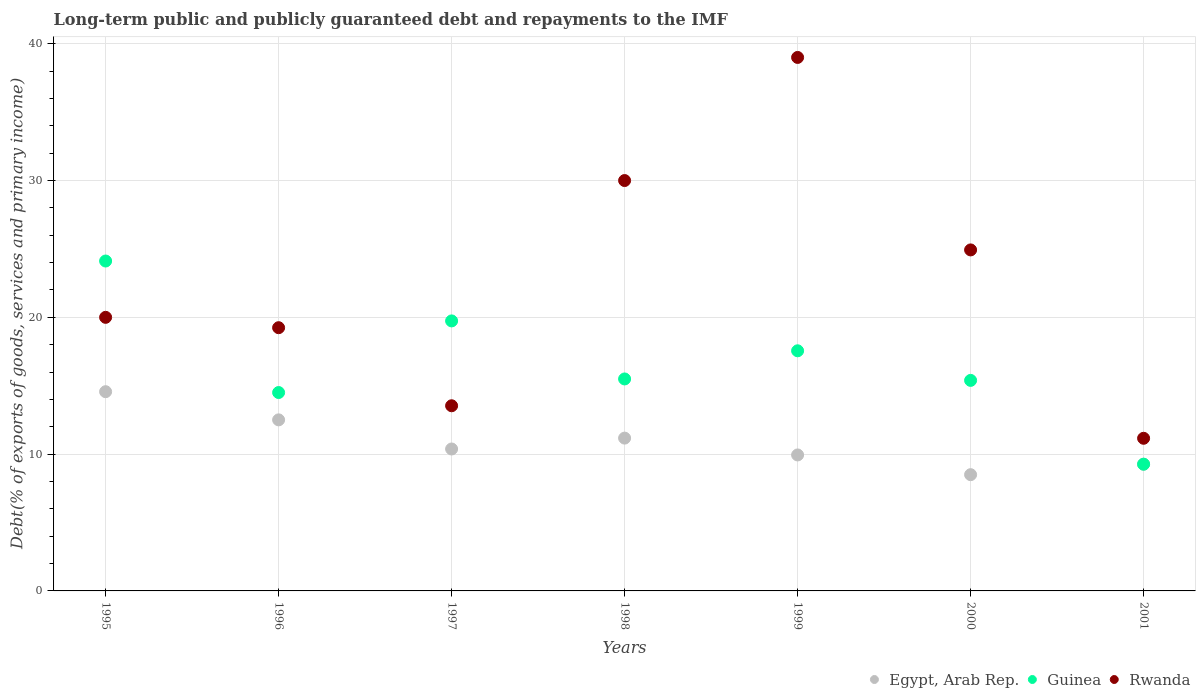How many different coloured dotlines are there?
Your answer should be compact. 3. Is the number of dotlines equal to the number of legend labels?
Offer a very short reply. Yes. What is the debt and repayments in Guinea in 1995?
Your answer should be compact. 24.12. Across all years, what is the maximum debt and repayments in Rwanda?
Offer a terse response. 39. Across all years, what is the minimum debt and repayments in Rwanda?
Make the answer very short. 11.16. What is the total debt and repayments in Guinea in the graph?
Keep it short and to the point. 116.06. What is the difference between the debt and repayments in Guinea in 1995 and that in 1997?
Your answer should be very brief. 4.38. What is the difference between the debt and repayments in Guinea in 1997 and the debt and repayments in Rwanda in 2001?
Make the answer very short. 8.58. What is the average debt and repayments in Guinea per year?
Your answer should be very brief. 16.58. In the year 2001, what is the difference between the debt and repayments in Egypt, Arab Rep. and debt and repayments in Guinea?
Provide a short and direct response. -0. What is the ratio of the debt and repayments in Rwanda in 1999 to that in 2001?
Give a very brief answer. 3.5. Is the debt and repayments in Guinea in 1995 less than that in 1997?
Your response must be concise. No. Is the difference between the debt and repayments in Egypt, Arab Rep. in 1996 and 1997 greater than the difference between the debt and repayments in Guinea in 1996 and 1997?
Ensure brevity in your answer.  Yes. What is the difference between the highest and the second highest debt and repayments in Rwanda?
Offer a very short reply. 9. What is the difference between the highest and the lowest debt and repayments in Egypt, Arab Rep.?
Offer a very short reply. 6.07. In how many years, is the debt and repayments in Rwanda greater than the average debt and repayments in Rwanda taken over all years?
Make the answer very short. 3. Is it the case that in every year, the sum of the debt and repayments in Guinea and debt and repayments in Egypt, Arab Rep.  is greater than the debt and repayments in Rwanda?
Offer a terse response. No. Does the debt and repayments in Rwanda monotonically increase over the years?
Your response must be concise. No. Is the debt and repayments in Guinea strictly less than the debt and repayments in Rwanda over the years?
Offer a very short reply. No. How many dotlines are there?
Keep it short and to the point. 3. What is the difference between two consecutive major ticks on the Y-axis?
Provide a succinct answer. 10. Does the graph contain grids?
Provide a succinct answer. Yes. Where does the legend appear in the graph?
Keep it short and to the point. Bottom right. How many legend labels are there?
Provide a short and direct response. 3. How are the legend labels stacked?
Your answer should be compact. Horizontal. What is the title of the graph?
Offer a terse response. Long-term public and publicly guaranteed debt and repayments to the IMF. Does "Gabon" appear as one of the legend labels in the graph?
Your response must be concise. No. What is the label or title of the X-axis?
Your answer should be compact. Years. What is the label or title of the Y-axis?
Your answer should be very brief. Debt(% of exports of goods, services and primary income). What is the Debt(% of exports of goods, services and primary income) of Egypt, Arab Rep. in 1995?
Make the answer very short. 14.56. What is the Debt(% of exports of goods, services and primary income) of Guinea in 1995?
Your response must be concise. 24.12. What is the Debt(% of exports of goods, services and primary income) of Rwanda in 1995?
Provide a succinct answer. 20. What is the Debt(% of exports of goods, services and primary income) of Egypt, Arab Rep. in 1996?
Offer a very short reply. 12.51. What is the Debt(% of exports of goods, services and primary income) in Guinea in 1996?
Give a very brief answer. 14.5. What is the Debt(% of exports of goods, services and primary income) of Rwanda in 1996?
Your answer should be very brief. 19.24. What is the Debt(% of exports of goods, services and primary income) of Egypt, Arab Rep. in 1997?
Keep it short and to the point. 10.38. What is the Debt(% of exports of goods, services and primary income) in Guinea in 1997?
Provide a short and direct response. 19.74. What is the Debt(% of exports of goods, services and primary income) in Rwanda in 1997?
Offer a terse response. 13.54. What is the Debt(% of exports of goods, services and primary income) of Egypt, Arab Rep. in 1998?
Ensure brevity in your answer.  11.17. What is the Debt(% of exports of goods, services and primary income) of Guinea in 1998?
Ensure brevity in your answer.  15.5. What is the Debt(% of exports of goods, services and primary income) in Rwanda in 1998?
Your answer should be very brief. 30. What is the Debt(% of exports of goods, services and primary income) of Egypt, Arab Rep. in 1999?
Your answer should be compact. 9.94. What is the Debt(% of exports of goods, services and primary income) of Guinea in 1999?
Provide a succinct answer. 17.55. What is the Debt(% of exports of goods, services and primary income) of Rwanda in 1999?
Give a very brief answer. 39. What is the Debt(% of exports of goods, services and primary income) in Egypt, Arab Rep. in 2000?
Keep it short and to the point. 8.5. What is the Debt(% of exports of goods, services and primary income) of Guinea in 2000?
Offer a terse response. 15.39. What is the Debt(% of exports of goods, services and primary income) in Rwanda in 2000?
Offer a very short reply. 24.93. What is the Debt(% of exports of goods, services and primary income) in Egypt, Arab Rep. in 2001?
Provide a succinct answer. 9.26. What is the Debt(% of exports of goods, services and primary income) of Guinea in 2001?
Make the answer very short. 9.26. What is the Debt(% of exports of goods, services and primary income) in Rwanda in 2001?
Keep it short and to the point. 11.16. Across all years, what is the maximum Debt(% of exports of goods, services and primary income) in Egypt, Arab Rep.?
Give a very brief answer. 14.56. Across all years, what is the maximum Debt(% of exports of goods, services and primary income) of Guinea?
Ensure brevity in your answer.  24.12. Across all years, what is the minimum Debt(% of exports of goods, services and primary income) of Egypt, Arab Rep.?
Provide a succinct answer. 8.5. Across all years, what is the minimum Debt(% of exports of goods, services and primary income) of Guinea?
Your response must be concise. 9.26. Across all years, what is the minimum Debt(% of exports of goods, services and primary income) of Rwanda?
Provide a succinct answer. 11.16. What is the total Debt(% of exports of goods, services and primary income) of Egypt, Arab Rep. in the graph?
Your answer should be compact. 76.32. What is the total Debt(% of exports of goods, services and primary income) in Guinea in the graph?
Keep it short and to the point. 116.06. What is the total Debt(% of exports of goods, services and primary income) of Rwanda in the graph?
Your response must be concise. 157.87. What is the difference between the Debt(% of exports of goods, services and primary income) of Egypt, Arab Rep. in 1995 and that in 1996?
Provide a short and direct response. 2.06. What is the difference between the Debt(% of exports of goods, services and primary income) in Guinea in 1995 and that in 1996?
Ensure brevity in your answer.  9.61. What is the difference between the Debt(% of exports of goods, services and primary income) of Rwanda in 1995 and that in 1996?
Your response must be concise. 0.76. What is the difference between the Debt(% of exports of goods, services and primary income) of Egypt, Arab Rep. in 1995 and that in 1997?
Ensure brevity in your answer.  4.19. What is the difference between the Debt(% of exports of goods, services and primary income) in Guinea in 1995 and that in 1997?
Provide a succinct answer. 4.38. What is the difference between the Debt(% of exports of goods, services and primary income) in Rwanda in 1995 and that in 1997?
Ensure brevity in your answer.  6.46. What is the difference between the Debt(% of exports of goods, services and primary income) in Egypt, Arab Rep. in 1995 and that in 1998?
Provide a short and direct response. 3.39. What is the difference between the Debt(% of exports of goods, services and primary income) of Guinea in 1995 and that in 1998?
Keep it short and to the point. 8.62. What is the difference between the Debt(% of exports of goods, services and primary income) in Rwanda in 1995 and that in 1998?
Ensure brevity in your answer.  -10. What is the difference between the Debt(% of exports of goods, services and primary income) in Egypt, Arab Rep. in 1995 and that in 1999?
Your answer should be very brief. 4.62. What is the difference between the Debt(% of exports of goods, services and primary income) of Guinea in 1995 and that in 1999?
Offer a terse response. 6.56. What is the difference between the Debt(% of exports of goods, services and primary income) in Rwanda in 1995 and that in 1999?
Give a very brief answer. -19. What is the difference between the Debt(% of exports of goods, services and primary income) in Egypt, Arab Rep. in 1995 and that in 2000?
Give a very brief answer. 6.07. What is the difference between the Debt(% of exports of goods, services and primary income) in Guinea in 1995 and that in 2000?
Provide a succinct answer. 8.73. What is the difference between the Debt(% of exports of goods, services and primary income) in Rwanda in 1995 and that in 2000?
Ensure brevity in your answer.  -4.93. What is the difference between the Debt(% of exports of goods, services and primary income) in Egypt, Arab Rep. in 1995 and that in 2001?
Your response must be concise. 5.3. What is the difference between the Debt(% of exports of goods, services and primary income) in Guinea in 1995 and that in 2001?
Your response must be concise. 14.85. What is the difference between the Debt(% of exports of goods, services and primary income) of Rwanda in 1995 and that in 2001?
Provide a short and direct response. 8.84. What is the difference between the Debt(% of exports of goods, services and primary income) of Egypt, Arab Rep. in 1996 and that in 1997?
Keep it short and to the point. 2.13. What is the difference between the Debt(% of exports of goods, services and primary income) in Guinea in 1996 and that in 1997?
Provide a succinct answer. -5.24. What is the difference between the Debt(% of exports of goods, services and primary income) of Rwanda in 1996 and that in 1997?
Your answer should be very brief. 5.71. What is the difference between the Debt(% of exports of goods, services and primary income) of Egypt, Arab Rep. in 1996 and that in 1998?
Provide a succinct answer. 1.33. What is the difference between the Debt(% of exports of goods, services and primary income) in Guinea in 1996 and that in 1998?
Keep it short and to the point. -0.99. What is the difference between the Debt(% of exports of goods, services and primary income) of Rwanda in 1996 and that in 1998?
Your response must be concise. -10.76. What is the difference between the Debt(% of exports of goods, services and primary income) in Egypt, Arab Rep. in 1996 and that in 1999?
Your answer should be very brief. 2.56. What is the difference between the Debt(% of exports of goods, services and primary income) in Guinea in 1996 and that in 1999?
Give a very brief answer. -3.05. What is the difference between the Debt(% of exports of goods, services and primary income) in Rwanda in 1996 and that in 1999?
Offer a very short reply. -19.76. What is the difference between the Debt(% of exports of goods, services and primary income) of Egypt, Arab Rep. in 1996 and that in 2000?
Your response must be concise. 4.01. What is the difference between the Debt(% of exports of goods, services and primary income) of Guinea in 1996 and that in 2000?
Give a very brief answer. -0.89. What is the difference between the Debt(% of exports of goods, services and primary income) of Rwanda in 1996 and that in 2000?
Offer a terse response. -5.69. What is the difference between the Debt(% of exports of goods, services and primary income) of Egypt, Arab Rep. in 1996 and that in 2001?
Make the answer very short. 3.24. What is the difference between the Debt(% of exports of goods, services and primary income) of Guinea in 1996 and that in 2001?
Make the answer very short. 5.24. What is the difference between the Debt(% of exports of goods, services and primary income) of Rwanda in 1996 and that in 2001?
Offer a very short reply. 8.08. What is the difference between the Debt(% of exports of goods, services and primary income) in Egypt, Arab Rep. in 1997 and that in 1998?
Keep it short and to the point. -0.8. What is the difference between the Debt(% of exports of goods, services and primary income) of Guinea in 1997 and that in 1998?
Ensure brevity in your answer.  4.24. What is the difference between the Debt(% of exports of goods, services and primary income) of Rwanda in 1997 and that in 1998?
Make the answer very short. -16.46. What is the difference between the Debt(% of exports of goods, services and primary income) in Egypt, Arab Rep. in 1997 and that in 1999?
Your answer should be very brief. 0.44. What is the difference between the Debt(% of exports of goods, services and primary income) in Guinea in 1997 and that in 1999?
Your answer should be compact. 2.18. What is the difference between the Debt(% of exports of goods, services and primary income) in Rwanda in 1997 and that in 1999?
Provide a short and direct response. -25.46. What is the difference between the Debt(% of exports of goods, services and primary income) in Egypt, Arab Rep. in 1997 and that in 2000?
Offer a very short reply. 1.88. What is the difference between the Debt(% of exports of goods, services and primary income) in Guinea in 1997 and that in 2000?
Your answer should be very brief. 4.35. What is the difference between the Debt(% of exports of goods, services and primary income) of Rwanda in 1997 and that in 2000?
Offer a terse response. -11.39. What is the difference between the Debt(% of exports of goods, services and primary income) of Egypt, Arab Rep. in 1997 and that in 2001?
Your answer should be compact. 1.11. What is the difference between the Debt(% of exports of goods, services and primary income) in Guinea in 1997 and that in 2001?
Make the answer very short. 10.47. What is the difference between the Debt(% of exports of goods, services and primary income) of Rwanda in 1997 and that in 2001?
Make the answer very short. 2.38. What is the difference between the Debt(% of exports of goods, services and primary income) in Egypt, Arab Rep. in 1998 and that in 1999?
Provide a succinct answer. 1.23. What is the difference between the Debt(% of exports of goods, services and primary income) in Guinea in 1998 and that in 1999?
Your answer should be very brief. -2.06. What is the difference between the Debt(% of exports of goods, services and primary income) in Rwanda in 1998 and that in 1999?
Your answer should be compact. -9. What is the difference between the Debt(% of exports of goods, services and primary income) in Egypt, Arab Rep. in 1998 and that in 2000?
Offer a very short reply. 2.67. What is the difference between the Debt(% of exports of goods, services and primary income) of Guinea in 1998 and that in 2000?
Provide a short and direct response. 0.11. What is the difference between the Debt(% of exports of goods, services and primary income) of Rwanda in 1998 and that in 2000?
Offer a very short reply. 5.07. What is the difference between the Debt(% of exports of goods, services and primary income) of Egypt, Arab Rep. in 1998 and that in 2001?
Your answer should be very brief. 1.91. What is the difference between the Debt(% of exports of goods, services and primary income) of Guinea in 1998 and that in 2001?
Offer a very short reply. 6.23. What is the difference between the Debt(% of exports of goods, services and primary income) in Rwanda in 1998 and that in 2001?
Give a very brief answer. 18.84. What is the difference between the Debt(% of exports of goods, services and primary income) in Egypt, Arab Rep. in 1999 and that in 2000?
Keep it short and to the point. 1.44. What is the difference between the Debt(% of exports of goods, services and primary income) in Guinea in 1999 and that in 2000?
Provide a succinct answer. 2.16. What is the difference between the Debt(% of exports of goods, services and primary income) in Rwanda in 1999 and that in 2000?
Your answer should be compact. 14.07. What is the difference between the Debt(% of exports of goods, services and primary income) of Egypt, Arab Rep. in 1999 and that in 2001?
Ensure brevity in your answer.  0.68. What is the difference between the Debt(% of exports of goods, services and primary income) in Guinea in 1999 and that in 2001?
Your answer should be very brief. 8.29. What is the difference between the Debt(% of exports of goods, services and primary income) in Rwanda in 1999 and that in 2001?
Offer a very short reply. 27.84. What is the difference between the Debt(% of exports of goods, services and primary income) in Egypt, Arab Rep. in 2000 and that in 2001?
Ensure brevity in your answer.  -0.76. What is the difference between the Debt(% of exports of goods, services and primary income) in Guinea in 2000 and that in 2001?
Offer a very short reply. 6.13. What is the difference between the Debt(% of exports of goods, services and primary income) in Rwanda in 2000 and that in 2001?
Provide a short and direct response. 13.77. What is the difference between the Debt(% of exports of goods, services and primary income) in Egypt, Arab Rep. in 1995 and the Debt(% of exports of goods, services and primary income) in Guinea in 1996?
Make the answer very short. 0.06. What is the difference between the Debt(% of exports of goods, services and primary income) in Egypt, Arab Rep. in 1995 and the Debt(% of exports of goods, services and primary income) in Rwanda in 1996?
Give a very brief answer. -4.68. What is the difference between the Debt(% of exports of goods, services and primary income) in Guinea in 1995 and the Debt(% of exports of goods, services and primary income) in Rwanda in 1996?
Offer a terse response. 4.87. What is the difference between the Debt(% of exports of goods, services and primary income) of Egypt, Arab Rep. in 1995 and the Debt(% of exports of goods, services and primary income) of Guinea in 1997?
Give a very brief answer. -5.17. What is the difference between the Debt(% of exports of goods, services and primary income) of Egypt, Arab Rep. in 1995 and the Debt(% of exports of goods, services and primary income) of Rwanda in 1997?
Your response must be concise. 1.03. What is the difference between the Debt(% of exports of goods, services and primary income) in Guinea in 1995 and the Debt(% of exports of goods, services and primary income) in Rwanda in 1997?
Offer a terse response. 10.58. What is the difference between the Debt(% of exports of goods, services and primary income) of Egypt, Arab Rep. in 1995 and the Debt(% of exports of goods, services and primary income) of Guinea in 1998?
Offer a terse response. -0.93. What is the difference between the Debt(% of exports of goods, services and primary income) of Egypt, Arab Rep. in 1995 and the Debt(% of exports of goods, services and primary income) of Rwanda in 1998?
Ensure brevity in your answer.  -15.44. What is the difference between the Debt(% of exports of goods, services and primary income) of Guinea in 1995 and the Debt(% of exports of goods, services and primary income) of Rwanda in 1998?
Provide a succinct answer. -5.88. What is the difference between the Debt(% of exports of goods, services and primary income) in Egypt, Arab Rep. in 1995 and the Debt(% of exports of goods, services and primary income) in Guinea in 1999?
Make the answer very short. -2.99. What is the difference between the Debt(% of exports of goods, services and primary income) in Egypt, Arab Rep. in 1995 and the Debt(% of exports of goods, services and primary income) in Rwanda in 1999?
Keep it short and to the point. -24.44. What is the difference between the Debt(% of exports of goods, services and primary income) in Guinea in 1995 and the Debt(% of exports of goods, services and primary income) in Rwanda in 1999?
Offer a very short reply. -14.88. What is the difference between the Debt(% of exports of goods, services and primary income) in Egypt, Arab Rep. in 1995 and the Debt(% of exports of goods, services and primary income) in Guinea in 2000?
Your response must be concise. -0.83. What is the difference between the Debt(% of exports of goods, services and primary income) in Egypt, Arab Rep. in 1995 and the Debt(% of exports of goods, services and primary income) in Rwanda in 2000?
Make the answer very short. -10.36. What is the difference between the Debt(% of exports of goods, services and primary income) in Guinea in 1995 and the Debt(% of exports of goods, services and primary income) in Rwanda in 2000?
Your response must be concise. -0.81. What is the difference between the Debt(% of exports of goods, services and primary income) in Egypt, Arab Rep. in 1995 and the Debt(% of exports of goods, services and primary income) in Guinea in 2001?
Keep it short and to the point. 5.3. What is the difference between the Debt(% of exports of goods, services and primary income) of Egypt, Arab Rep. in 1995 and the Debt(% of exports of goods, services and primary income) of Rwanda in 2001?
Provide a succinct answer. 3.41. What is the difference between the Debt(% of exports of goods, services and primary income) in Guinea in 1995 and the Debt(% of exports of goods, services and primary income) in Rwanda in 2001?
Your response must be concise. 12.96. What is the difference between the Debt(% of exports of goods, services and primary income) in Egypt, Arab Rep. in 1996 and the Debt(% of exports of goods, services and primary income) in Guinea in 1997?
Provide a succinct answer. -7.23. What is the difference between the Debt(% of exports of goods, services and primary income) in Egypt, Arab Rep. in 1996 and the Debt(% of exports of goods, services and primary income) in Rwanda in 1997?
Offer a very short reply. -1.03. What is the difference between the Debt(% of exports of goods, services and primary income) of Guinea in 1996 and the Debt(% of exports of goods, services and primary income) of Rwanda in 1997?
Your answer should be compact. 0.97. What is the difference between the Debt(% of exports of goods, services and primary income) of Egypt, Arab Rep. in 1996 and the Debt(% of exports of goods, services and primary income) of Guinea in 1998?
Give a very brief answer. -2.99. What is the difference between the Debt(% of exports of goods, services and primary income) in Egypt, Arab Rep. in 1996 and the Debt(% of exports of goods, services and primary income) in Rwanda in 1998?
Provide a short and direct response. -17.49. What is the difference between the Debt(% of exports of goods, services and primary income) of Guinea in 1996 and the Debt(% of exports of goods, services and primary income) of Rwanda in 1998?
Offer a terse response. -15.5. What is the difference between the Debt(% of exports of goods, services and primary income) of Egypt, Arab Rep. in 1996 and the Debt(% of exports of goods, services and primary income) of Guinea in 1999?
Your answer should be compact. -5.05. What is the difference between the Debt(% of exports of goods, services and primary income) of Egypt, Arab Rep. in 1996 and the Debt(% of exports of goods, services and primary income) of Rwanda in 1999?
Give a very brief answer. -26.49. What is the difference between the Debt(% of exports of goods, services and primary income) of Guinea in 1996 and the Debt(% of exports of goods, services and primary income) of Rwanda in 1999?
Offer a terse response. -24.5. What is the difference between the Debt(% of exports of goods, services and primary income) in Egypt, Arab Rep. in 1996 and the Debt(% of exports of goods, services and primary income) in Guinea in 2000?
Give a very brief answer. -2.89. What is the difference between the Debt(% of exports of goods, services and primary income) of Egypt, Arab Rep. in 1996 and the Debt(% of exports of goods, services and primary income) of Rwanda in 2000?
Your answer should be compact. -12.42. What is the difference between the Debt(% of exports of goods, services and primary income) of Guinea in 1996 and the Debt(% of exports of goods, services and primary income) of Rwanda in 2000?
Offer a very short reply. -10.43. What is the difference between the Debt(% of exports of goods, services and primary income) of Egypt, Arab Rep. in 1996 and the Debt(% of exports of goods, services and primary income) of Guinea in 2001?
Your answer should be very brief. 3.24. What is the difference between the Debt(% of exports of goods, services and primary income) of Egypt, Arab Rep. in 1996 and the Debt(% of exports of goods, services and primary income) of Rwanda in 2001?
Ensure brevity in your answer.  1.35. What is the difference between the Debt(% of exports of goods, services and primary income) of Guinea in 1996 and the Debt(% of exports of goods, services and primary income) of Rwanda in 2001?
Keep it short and to the point. 3.34. What is the difference between the Debt(% of exports of goods, services and primary income) of Egypt, Arab Rep. in 1997 and the Debt(% of exports of goods, services and primary income) of Guinea in 1998?
Give a very brief answer. -5.12. What is the difference between the Debt(% of exports of goods, services and primary income) in Egypt, Arab Rep. in 1997 and the Debt(% of exports of goods, services and primary income) in Rwanda in 1998?
Provide a short and direct response. -19.62. What is the difference between the Debt(% of exports of goods, services and primary income) in Guinea in 1997 and the Debt(% of exports of goods, services and primary income) in Rwanda in 1998?
Ensure brevity in your answer.  -10.26. What is the difference between the Debt(% of exports of goods, services and primary income) in Egypt, Arab Rep. in 1997 and the Debt(% of exports of goods, services and primary income) in Guinea in 1999?
Keep it short and to the point. -7.18. What is the difference between the Debt(% of exports of goods, services and primary income) of Egypt, Arab Rep. in 1997 and the Debt(% of exports of goods, services and primary income) of Rwanda in 1999?
Make the answer very short. -28.62. What is the difference between the Debt(% of exports of goods, services and primary income) in Guinea in 1997 and the Debt(% of exports of goods, services and primary income) in Rwanda in 1999?
Your response must be concise. -19.26. What is the difference between the Debt(% of exports of goods, services and primary income) in Egypt, Arab Rep. in 1997 and the Debt(% of exports of goods, services and primary income) in Guinea in 2000?
Offer a terse response. -5.02. What is the difference between the Debt(% of exports of goods, services and primary income) of Egypt, Arab Rep. in 1997 and the Debt(% of exports of goods, services and primary income) of Rwanda in 2000?
Your answer should be very brief. -14.55. What is the difference between the Debt(% of exports of goods, services and primary income) in Guinea in 1997 and the Debt(% of exports of goods, services and primary income) in Rwanda in 2000?
Offer a very short reply. -5.19. What is the difference between the Debt(% of exports of goods, services and primary income) in Egypt, Arab Rep. in 1997 and the Debt(% of exports of goods, services and primary income) in Rwanda in 2001?
Your response must be concise. -0.78. What is the difference between the Debt(% of exports of goods, services and primary income) of Guinea in 1997 and the Debt(% of exports of goods, services and primary income) of Rwanda in 2001?
Make the answer very short. 8.58. What is the difference between the Debt(% of exports of goods, services and primary income) of Egypt, Arab Rep. in 1998 and the Debt(% of exports of goods, services and primary income) of Guinea in 1999?
Your response must be concise. -6.38. What is the difference between the Debt(% of exports of goods, services and primary income) of Egypt, Arab Rep. in 1998 and the Debt(% of exports of goods, services and primary income) of Rwanda in 1999?
Offer a terse response. -27.83. What is the difference between the Debt(% of exports of goods, services and primary income) of Guinea in 1998 and the Debt(% of exports of goods, services and primary income) of Rwanda in 1999?
Keep it short and to the point. -23.5. What is the difference between the Debt(% of exports of goods, services and primary income) in Egypt, Arab Rep. in 1998 and the Debt(% of exports of goods, services and primary income) in Guinea in 2000?
Ensure brevity in your answer.  -4.22. What is the difference between the Debt(% of exports of goods, services and primary income) in Egypt, Arab Rep. in 1998 and the Debt(% of exports of goods, services and primary income) in Rwanda in 2000?
Offer a very short reply. -13.76. What is the difference between the Debt(% of exports of goods, services and primary income) in Guinea in 1998 and the Debt(% of exports of goods, services and primary income) in Rwanda in 2000?
Your answer should be compact. -9.43. What is the difference between the Debt(% of exports of goods, services and primary income) in Egypt, Arab Rep. in 1998 and the Debt(% of exports of goods, services and primary income) in Guinea in 2001?
Provide a succinct answer. 1.91. What is the difference between the Debt(% of exports of goods, services and primary income) in Egypt, Arab Rep. in 1998 and the Debt(% of exports of goods, services and primary income) in Rwanda in 2001?
Provide a short and direct response. 0.01. What is the difference between the Debt(% of exports of goods, services and primary income) of Guinea in 1998 and the Debt(% of exports of goods, services and primary income) of Rwanda in 2001?
Keep it short and to the point. 4.34. What is the difference between the Debt(% of exports of goods, services and primary income) in Egypt, Arab Rep. in 1999 and the Debt(% of exports of goods, services and primary income) in Guinea in 2000?
Ensure brevity in your answer.  -5.45. What is the difference between the Debt(% of exports of goods, services and primary income) in Egypt, Arab Rep. in 1999 and the Debt(% of exports of goods, services and primary income) in Rwanda in 2000?
Your answer should be compact. -14.99. What is the difference between the Debt(% of exports of goods, services and primary income) of Guinea in 1999 and the Debt(% of exports of goods, services and primary income) of Rwanda in 2000?
Offer a very short reply. -7.37. What is the difference between the Debt(% of exports of goods, services and primary income) in Egypt, Arab Rep. in 1999 and the Debt(% of exports of goods, services and primary income) in Guinea in 2001?
Offer a terse response. 0.68. What is the difference between the Debt(% of exports of goods, services and primary income) of Egypt, Arab Rep. in 1999 and the Debt(% of exports of goods, services and primary income) of Rwanda in 2001?
Provide a short and direct response. -1.22. What is the difference between the Debt(% of exports of goods, services and primary income) in Guinea in 1999 and the Debt(% of exports of goods, services and primary income) in Rwanda in 2001?
Your answer should be very brief. 6.4. What is the difference between the Debt(% of exports of goods, services and primary income) in Egypt, Arab Rep. in 2000 and the Debt(% of exports of goods, services and primary income) in Guinea in 2001?
Your response must be concise. -0.77. What is the difference between the Debt(% of exports of goods, services and primary income) of Egypt, Arab Rep. in 2000 and the Debt(% of exports of goods, services and primary income) of Rwanda in 2001?
Give a very brief answer. -2.66. What is the difference between the Debt(% of exports of goods, services and primary income) of Guinea in 2000 and the Debt(% of exports of goods, services and primary income) of Rwanda in 2001?
Ensure brevity in your answer.  4.23. What is the average Debt(% of exports of goods, services and primary income) in Egypt, Arab Rep. per year?
Provide a succinct answer. 10.9. What is the average Debt(% of exports of goods, services and primary income) in Guinea per year?
Offer a very short reply. 16.58. What is the average Debt(% of exports of goods, services and primary income) in Rwanda per year?
Give a very brief answer. 22.55. In the year 1995, what is the difference between the Debt(% of exports of goods, services and primary income) of Egypt, Arab Rep. and Debt(% of exports of goods, services and primary income) of Guinea?
Ensure brevity in your answer.  -9.55. In the year 1995, what is the difference between the Debt(% of exports of goods, services and primary income) of Egypt, Arab Rep. and Debt(% of exports of goods, services and primary income) of Rwanda?
Offer a terse response. -5.44. In the year 1995, what is the difference between the Debt(% of exports of goods, services and primary income) of Guinea and Debt(% of exports of goods, services and primary income) of Rwanda?
Provide a short and direct response. 4.12. In the year 1996, what is the difference between the Debt(% of exports of goods, services and primary income) in Egypt, Arab Rep. and Debt(% of exports of goods, services and primary income) in Guinea?
Make the answer very short. -2. In the year 1996, what is the difference between the Debt(% of exports of goods, services and primary income) of Egypt, Arab Rep. and Debt(% of exports of goods, services and primary income) of Rwanda?
Provide a short and direct response. -6.74. In the year 1996, what is the difference between the Debt(% of exports of goods, services and primary income) in Guinea and Debt(% of exports of goods, services and primary income) in Rwanda?
Your answer should be very brief. -4.74. In the year 1997, what is the difference between the Debt(% of exports of goods, services and primary income) in Egypt, Arab Rep. and Debt(% of exports of goods, services and primary income) in Guinea?
Ensure brevity in your answer.  -9.36. In the year 1997, what is the difference between the Debt(% of exports of goods, services and primary income) in Egypt, Arab Rep. and Debt(% of exports of goods, services and primary income) in Rwanda?
Make the answer very short. -3.16. In the year 1997, what is the difference between the Debt(% of exports of goods, services and primary income) of Guinea and Debt(% of exports of goods, services and primary income) of Rwanda?
Give a very brief answer. 6.2. In the year 1998, what is the difference between the Debt(% of exports of goods, services and primary income) in Egypt, Arab Rep. and Debt(% of exports of goods, services and primary income) in Guinea?
Your response must be concise. -4.32. In the year 1998, what is the difference between the Debt(% of exports of goods, services and primary income) in Egypt, Arab Rep. and Debt(% of exports of goods, services and primary income) in Rwanda?
Give a very brief answer. -18.83. In the year 1998, what is the difference between the Debt(% of exports of goods, services and primary income) of Guinea and Debt(% of exports of goods, services and primary income) of Rwanda?
Give a very brief answer. -14.5. In the year 1999, what is the difference between the Debt(% of exports of goods, services and primary income) of Egypt, Arab Rep. and Debt(% of exports of goods, services and primary income) of Guinea?
Provide a succinct answer. -7.61. In the year 1999, what is the difference between the Debt(% of exports of goods, services and primary income) in Egypt, Arab Rep. and Debt(% of exports of goods, services and primary income) in Rwanda?
Your response must be concise. -29.06. In the year 1999, what is the difference between the Debt(% of exports of goods, services and primary income) in Guinea and Debt(% of exports of goods, services and primary income) in Rwanda?
Your response must be concise. -21.45. In the year 2000, what is the difference between the Debt(% of exports of goods, services and primary income) of Egypt, Arab Rep. and Debt(% of exports of goods, services and primary income) of Guinea?
Make the answer very short. -6.89. In the year 2000, what is the difference between the Debt(% of exports of goods, services and primary income) in Egypt, Arab Rep. and Debt(% of exports of goods, services and primary income) in Rwanda?
Offer a very short reply. -16.43. In the year 2000, what is the difference between the Debt(% of exports of goods, services and primary income) in Guinea and Debt(% of exports of goods, services and primary income) in Rwanda?
Provide a short and direct response. -9.54. In the year 2001, what is the difference between the Debt(% of exports of goods, services and primary income) of Egypt, Arab Rep. and Debt(% of exports of goods, services and primary income) of Guinea?
Provide a succinct answer. -0. In the year 2001, what is the difference between the Debt(% of exports of goods, services and primary income) in Egypt, Arab Rep. and Debt(% of exports of goods, services and primary income) in Rwanda?
Your answer should be compact. -1.9. In the year 2001, what is the difference between the Debt(% of exports of goods, services and primary income) in Guinea and Debt(% of exports of goods, services and primary income) in Rwanda?
Your answer should be compact. -1.89. What is the ratio of the Debt(% of exports of goods, services and primary income) in Egypt, Arab Rep. in 1995 to that in 1996?
Ensure brevity in your answer.  1.16. What is the ratio of the Debt(% of exports of goods, services and primary income) in Guinea in 1995 to that in 1996?
Give a very brief answer. 1.66. What is the ratio of the Debt(% of exports of goods, services and primary income) of Rwanda in 1995 to that in 1996?
Provide a succinct answer. 1.04. What is the ratio of the Debt(% of exports of goods, services and primary income) in Egypt, Arab Rep. in 1995 to that in 1997?
Provide a succinct answer. 1.4. What is the ratio of the Debt(% of exports of goods, services and primary income) of Guinea in 1995 to that in 1997?
Keep it short and to the point. 1.22. What is the ratio of the Debt(% of exports of goods, services and primary income) of Rwanda in 1995 to that in 1997?
Your response must be concise. 1.48. What is the ratio of the Debt(% of exports of goods, services and primary income) of Egypt, Arab Rep. in 1995 to that in 1998?
Make the answer very short. 1.3. What is the ratio of the Debt(% of exports of goods, services and primary income) of Guinea in 1995 to that in 1998?
Provide a short and direct response. 1.56. What is the ratio of the Debt(% of exports of goods, services and primary income) in Rwanda in 1995 to that in 1998?
Your answer should be compact. 0.67. What is the ratio of the Debt(% of exports of goods, services and primary income) in Egypt, Arab Rep. in 1995 to that in 1999?
Keep it short and to the point. 1.47. What is the ratio of the Debt(% of exports of goods, services and primary income) in Guinea in 1995 to that in 1999?
Your answer should be compact. 1.37. What is the ratio of the Debt(% of exports of goods, services and primary income) in Rwanda in 1995 to that in 1999?
Offer a terse response. 0.51. What is the ratio of the Debt(% of exports of goods, services and primary income) in Egypt, Arab Rep. in 1995 to that in 2000?
Provide a short and direct response. 1.71. What is the ratio of the Debt(% of exports of goods, services and primary income) in Guinea in 1995 to that in 2000?
Your answer should be very brief. 1.57. What is the ratio of the Debt(% of exports of goods, services and primary income) of Rwanda in 1995 to that in 2000?
Your answer should be very brief. 0.8. What is the ratio of the Debt(% of exports of goods, services and primary income) in Egypt, Arab Rep. in 1995 to that in 2001?
Ensure brevity in your answer.  1.57. What is the ratio of the Debt(% of exports of goods, services and primary income) of Guinea in 1995 to that in 2001?
Give a very brief answer. 2.6. What is the ratio of the Debt(% of exports of goods, services and primary income) of Rwanda in 1995 to that in 2001?
Your answer should be compact. 1.79. What is the ratio of the Debt(% of exports of goods, services and primary income) of Egypt, Arab Rep. in 1996 to that in 1997?
Your answer should be compact. 1.21. What is the ratio of the Debt(% of exports of goods, services and primary income) in Guinea in 1996 to that in 1997?
Offer a terse response. 0.73. What is the ratio of the Debt(% of exports of goods, services and primary income) of Rwanda in 1996 to that in 1997?
Your answer should be very brief. 1.42. What is the ratio of the Debt(% of exports of goods, services and primary income) of Egypt, Arab Rep. in 1996 to that in 1998?
Keep it short and to the point. 1.12. What is the ratio of the Debt(% of exports of goods, services and primary income) in Guinea in 1996 to that in 1998?
Keep it short and to the point. 0.94. What is the ratio of the Debt(% of exports of goods, services and primary income) in Rwanda in 1996 to that in 1998?
Your answer should be compact. 0.64. What is the ratio of the Debt(% of exports of goods, services and primary income) of Egypt, Arab Rep. in 1996 to that in 1999?
Provide a succinct answer. 1.26. What is the ratio of the Debt(% of exports of goods, services and primary income) of Guinea in 1996 to that in 1999?
Your response must be concise. 0.83. What is the ratio of the Debt(% of exports of goods, services and primary income) of Rwanda in 1996 to that in 1999?
Make the answer very short. 0.49. What is the ratio of the Debt(% of exports of goods, services and primary income) of Egypt, Arab Rep. in 1996 to that in 2000?
Offer a terse response. 1.47. What is the ratio of the Debt(% of exports of goods, services and primary income) in Guinea in 1996 to that in 2000?
Provide a succinct answer. 0.94. What is the ratio of the Debt(% of exports of goods, services and primary income) of Rwanda in 1996 to that in 2000?
Your answer should be compact. 0.77. What is the ratio of the Debt(% of exports of goods, services and primary income) of Egypt, Arab Rep. in 1996 to that in 2001?
Keep it short and to the point. 1.35. What is the ratio of the Debt(% of exports of goods, services and primary income) in Guinea in 1996 to that in 2001?
Provide a short and direct response. 1.57. What is the ratio of the Debt(% of exports of goods, services and primary income) of Rwanda in 1996 to that in 2001?
Your answer should be compact. 1.72. What is the ratio of the Debt(% of exports of goods, services and primary income) in Egypt, Arab Rep. in 1997 to that in 1998?
Your answer should be very brief. 0.93. What is the ratio of the Debt(% of exports of goods, services and primary income) in Guinea in 1997 to that in 1998?
Provide a short and direct response. 1.27. What is the ratio of the Debt(% of exports of goods, services and primary income) of Rwanda in 1997 to that in 1998?
Provide a succinct answer. 0.45. What is the ratio of the Debt(% of exports of goods, services and primary income) in Egypt, Arab Rep. in 1997 to that in 1999?
Give a very brief answer. 1.04. What is the ratio of the Debt(% of exports of goods, services and primary income) of Guinea in 1997 to that in 1999?
Provide a succinct answer. 1.12. What is the ratio of the Debt(% of exports of goods, services and primary income) of Rwanda in 1997 to that in 1999?
Offer a terse response. 0.35. What is the ratio of the Debt(% of exports of goods, services and primary income) of Egypt, Arab Rep. in 1997 to that in 2000?
Make the answer very short. 1.22. What is the ratio of the Debt(% of exports of goods, services and primary income) of Guinea in 1997 to that in 2000?
Provide a short and direct response. 1.28. What is the ratio of the Debt(% of exports of goods, services and primary income) in Rwanda in 1997 to that in 2000?
Keep it short and to the point. 0.54. What is the ratio of the Debt(% of exports of goods, services and primary income) of Egypt, Arab Rep. in 1997 to that in 2001?
Provide a succinct answer. 1.12. What is the ratio of the Debt(% of exports of goods, services and primary income) of Guinea in 1997 to that in 2001?
Your answer should be very brief. 2.13. What is the ratio of the Debt(% of exports of goods, services and primary income) in Rwanda in 1997 to that in 2001?
Your response must be concise. 1.21. What is the ratio of the Debt(% of exports of goods, services and primary income) of Egypt, Arab Rep. in 1998 to that in 1999?
Offer a very short reply. 1.12. What is the ratio of the Debt(% of exports of goods, services and primary income) in Guinea in 1998 to that in 1999?
Offer a very short reply. 0.88. What is the ratio of the Debt(% of exports of goods, services and primary income) of Rwanda in 1998 to that in 1999?
Offer a terse response. 0.77. What is the ratio of the Debt(% of exports of goods, services and primary income) of Egypt, Arab Rep. in 1998 to that in 2000?
Give a very brief answer. 1.31. What is the ratio of the Debt(% of exports of goods, services and primary income) in Guinea in 1998 to that in 2000?
Keep it short and to the point. 1.01. What is the ratio of the Debt(% of exports of goods, services and primary income) in Rwanda in 1998 to that in 2000?
Offer a terse response. 1.2. What is the ratio of the Debt(% of exports of goods, services and primary income) in Egypt, Arab Rep. in 1998 to that in 2001?
Ensure brevity in your answer.  1.21. What is the ratio of the Debt(% of exports of goods, services and primary income) in Guinea in 1998 to that in 2001?
Provide a short and direct response. 1.67. What is the ratio of the Debt(% of exports of goods, services and primary income) of Rwanda in 1998 to that in 2001?
Your answer should be very brief. 2.69. What is the ratio of the Debt(% of exports of goods, services and primary income) in Egypt, Arab Rep. in 1999 to that in 2000?
Your response must be concise. 1.17. What is the ratio of the Debt(% of exports of goods, services and primary income) in Guinea in 1999 to that in 2000?
Give a very brief answer. 1.14. What is the ratio of the Debt(% of exports of goods, services and primary income) of Rwanda in 1999 to that in 2000?
Provide a short and direct response. 1.56. What is the ratio of the Debt(% of exports of goods, services and primary income) of Egypt, Arab Rep. in 1999 to that in 2001?
Offer a terse response. 1.07. What is the ratio of the Debt(% of exports of goods, services and primary income) of Guinea in 1999 to that in 2001?
Your answer should be very brief. 1.89. What is the ratio of the Debt(% of exports of goods, services and primary income) in Rwanda in 1999 to that in 2001?
Offer a terse response. 3.5. What is the ratio of the Debt(% of exports of goods, services and primary income) in Egypt, Arab Rep. in 2000 to that in 2001?
Offer a very short reply. 0.92. What is the ratio of the Debt(% of exports of goods, services and primary income) in Guinea in 2000 to that in 2001?
Your answer should be compact. 1.66. What is the ratio of the Debt(% of exports of goods, services and primary income) in Rwanda in 2000 to that in 2001?
Ensure brevity in your answer.  2.23. What is the difference between the highest and the second highest Debt(% of exports of goods, services and primary income) in Egypt, Arab Rep.?
Your answer should be compact. 2.06. What is the difference between the highest and the second highest Debt(% of exports of goods, services and primary income) of Guinea?
Your response must be concise. 4.38. What is the difference between the highest and the second highest Debt(% of exports of goods, services and primary income) of Rwanda?
Your answer should be very brief. 9. What is the difference between the highest and the lowest Debt(% of exports of goods, services and primary income) of Egypt, Arab Rep.?
Your answer should be very brief. 6.07. What is the difference between the highest and the lowest Debt(% of exports of goods, services and primary income) of Guinea?
Your answer should be compact. 14.85. What is the difference between the highest and the lowest Debt(% of exports of goods, services and primary income) of Rwanda?
Provide a succinct answer. 27.84. 